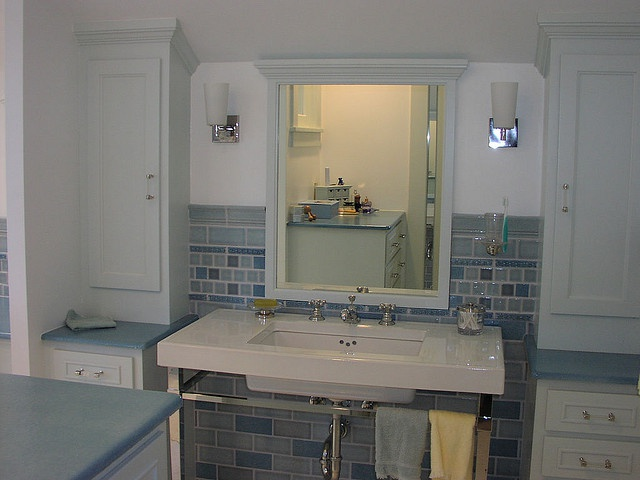Describe the objects in this image and their specific colors. I can see sink in darkgray and gray tones, cup in darkgray, gray, and black tones, cup in darkgray, gray, and lightgray tones, and toothbrush in darkgray, teal, and gray tones in this image. 